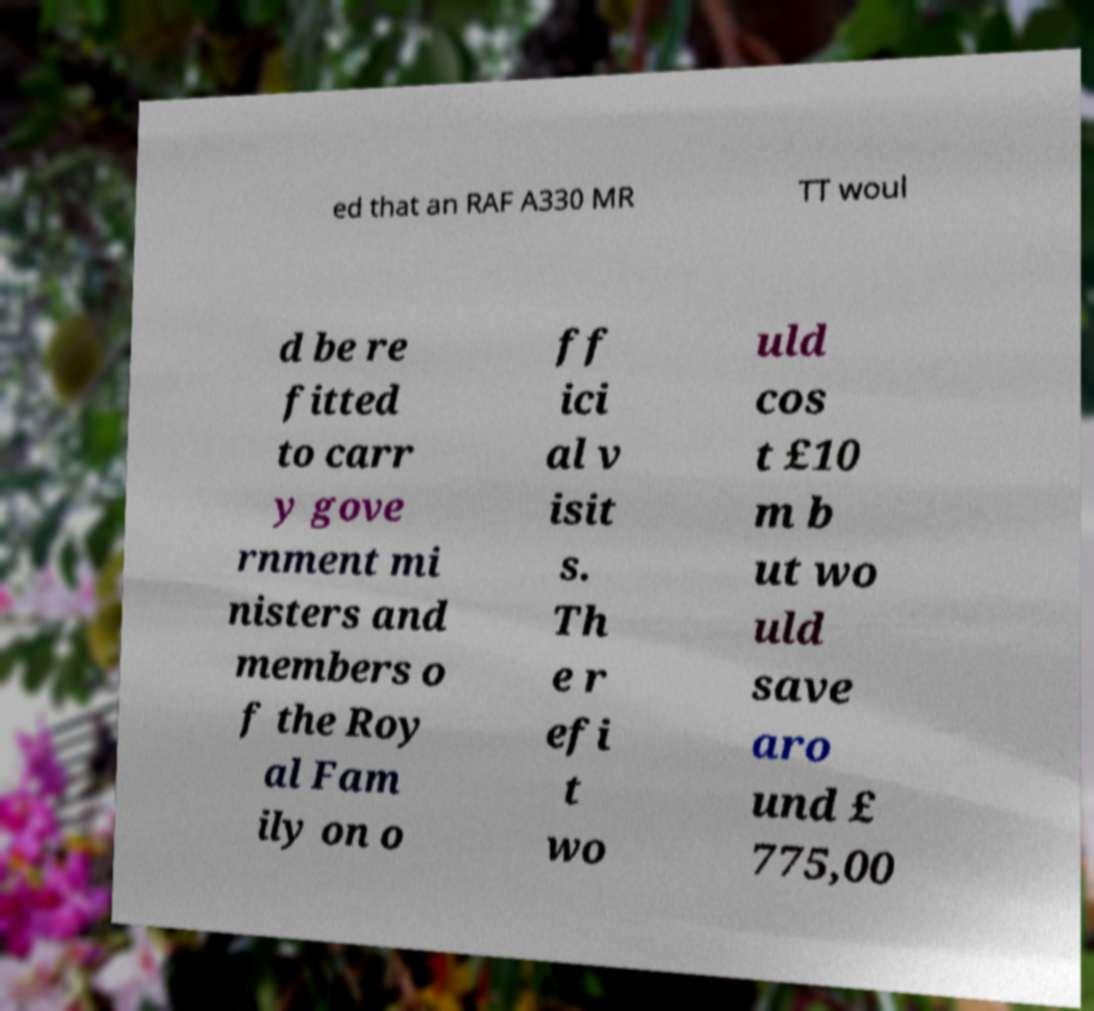Could you extract and type out the text from this image? ed that an RAF A330 MR TT woul d be re fitted to carr y gove rnment mi nisters and members o f the Roy al Fam ily on o ff ici al v isit s. Th e r efi t wo uld cos t £10 m b ut wo uld save aro und £ 775,00 